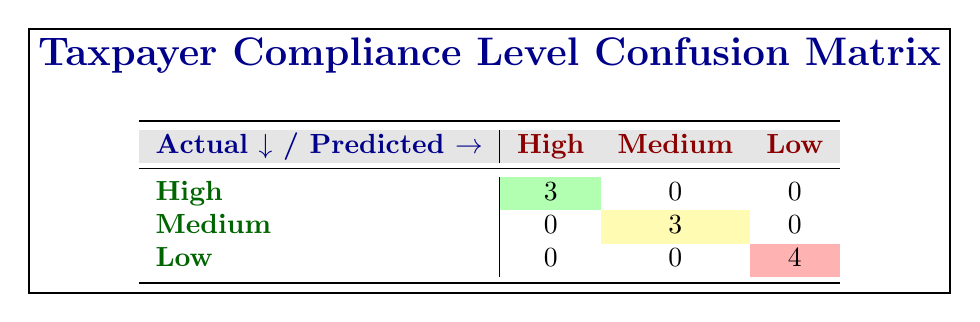What is the total number of taxpayers classified as having high compliance? The confusion matrix shows 3 taxpayers classified as high compliance. We can see this directly from the cell in the "High" row and the "High" column, which holds the value 3.
Answer: 3 How many taxpayers were predicted to have low compliance? From the table, we observe that in the "Low" column, there are 4 taxpayers predicted to have low compliance. This is seen in the cell under the "Low" row and "Low" column, which shows the value 4.
Answer: 4 Is there any taxpayer predicted to have a medium compliance level who was actually low compliance? By inspecting the matrix, in the "Medium" row and "Low" column, the value is 0, indicating that no taxpayer was predicted to have medium compliance while actually being low compliance. Therefore, the answer is no.
Answer: No What is the sum of all taxpayers classified as medium compliance both predicted and actual? The table shows that there are 3 actual taxpayers that are classified as medium compliance (in the "Medium" row under "High" column) and 3 that are predicted to be medium compliance (the same cell for "Medium" row, "Medium" column). Adding these values gives us 3 + 3 = 6 as the total number of medium compliance taxpayers in both predictions and actuals.
Answer: 6 How many actual taxpayers classified as high compliance were predicted correctly? Looking at the table, we see that the total in the "High" row under "High" column is 3, which represents those taxpayers who were correctly predicted to have high compliance. Thus, the answer is 3.
Answer: 3 Are there any taxpayers with high actual compliance status that were incorrectly predicted? In the table, all predictions under high compliance for actual high compliance taxpayers equal to 3, indicating that there are no incorrect predictions for those predicted. Therefore, the answer is no.
Answer: No What is the percentage of taxpayers classified as low compliance that were predicted as low compliance? From the table, we see that 4 taxpayers are classified as low compliance (actual) and out of them, all were predicted correctly under low compliance (0 in the "Low" row and "Medium" column and 0 in the "Low" row and "High" column). Therefore, the percentage is (4/4) * 100 = 100%.
Answer: 100% 